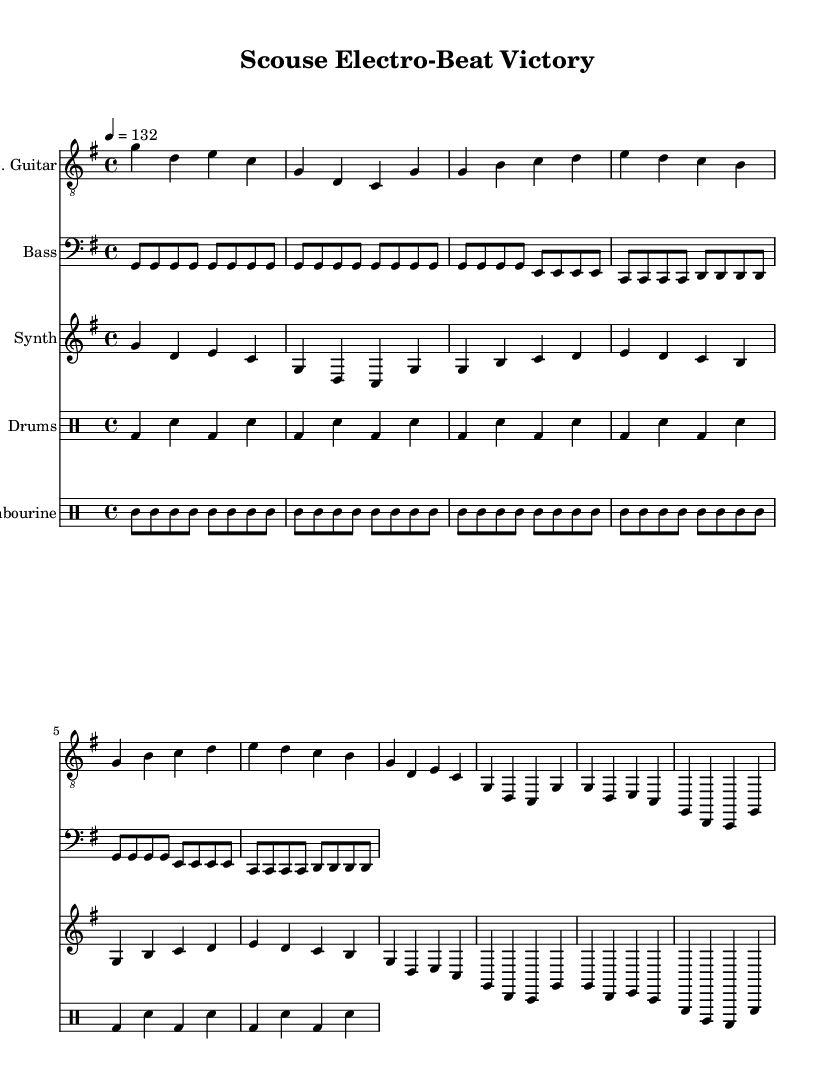What is the key signature of this music? The key signature is G major, which has one sharp (F#). It's indicated in the global settings in the code section.
Answer: G major What is the time signature of this music? The time signature is 4/4, as noted in the global settings at the beginning of the score. This means there are four beats in a measure, and a quarter note gets one beat.
Answer: 4/4 What is the tempo marking of the piece? The tempo marking indicates a speed of 132 beats per minute, specified in the global settings as '4 = 132'. This means that a quarter note is played at this speed.
Answer: 132 How many measures are there in the electric guitar part? To find the number of measures, you can count the groups of notes divided by the vertical lines indicating bar lines. There are ten measures in the electric guitar part.
Answer: 10 How many instruments are used in this score? The score features five distinct parts: electric guitar, bass, synth, drums, and tambourine. Each is presented in a separate staff, making it easy to identify them in the sheet music.
Answer: 5 What is the primary genre fusion of this piece? The primary genre fusion combines elements of electro-funk and Merseybeat, reflecting a lively and rhythmic sound ideal for game day excitement. This can be inferred from the energetic style marked by synths and strong beats.
Answer: Electro-funk and Merseybeat Which component indicates the rhythm in the drums part? The rhythm is indicated by the note values and the use of bass drum (bd) and snare (sn) notations within the drum part. Counting the notes shows the rhythmic pattern clearly in each measure, therefore establishing the overall groove.
Answer: Bass drum and snare 